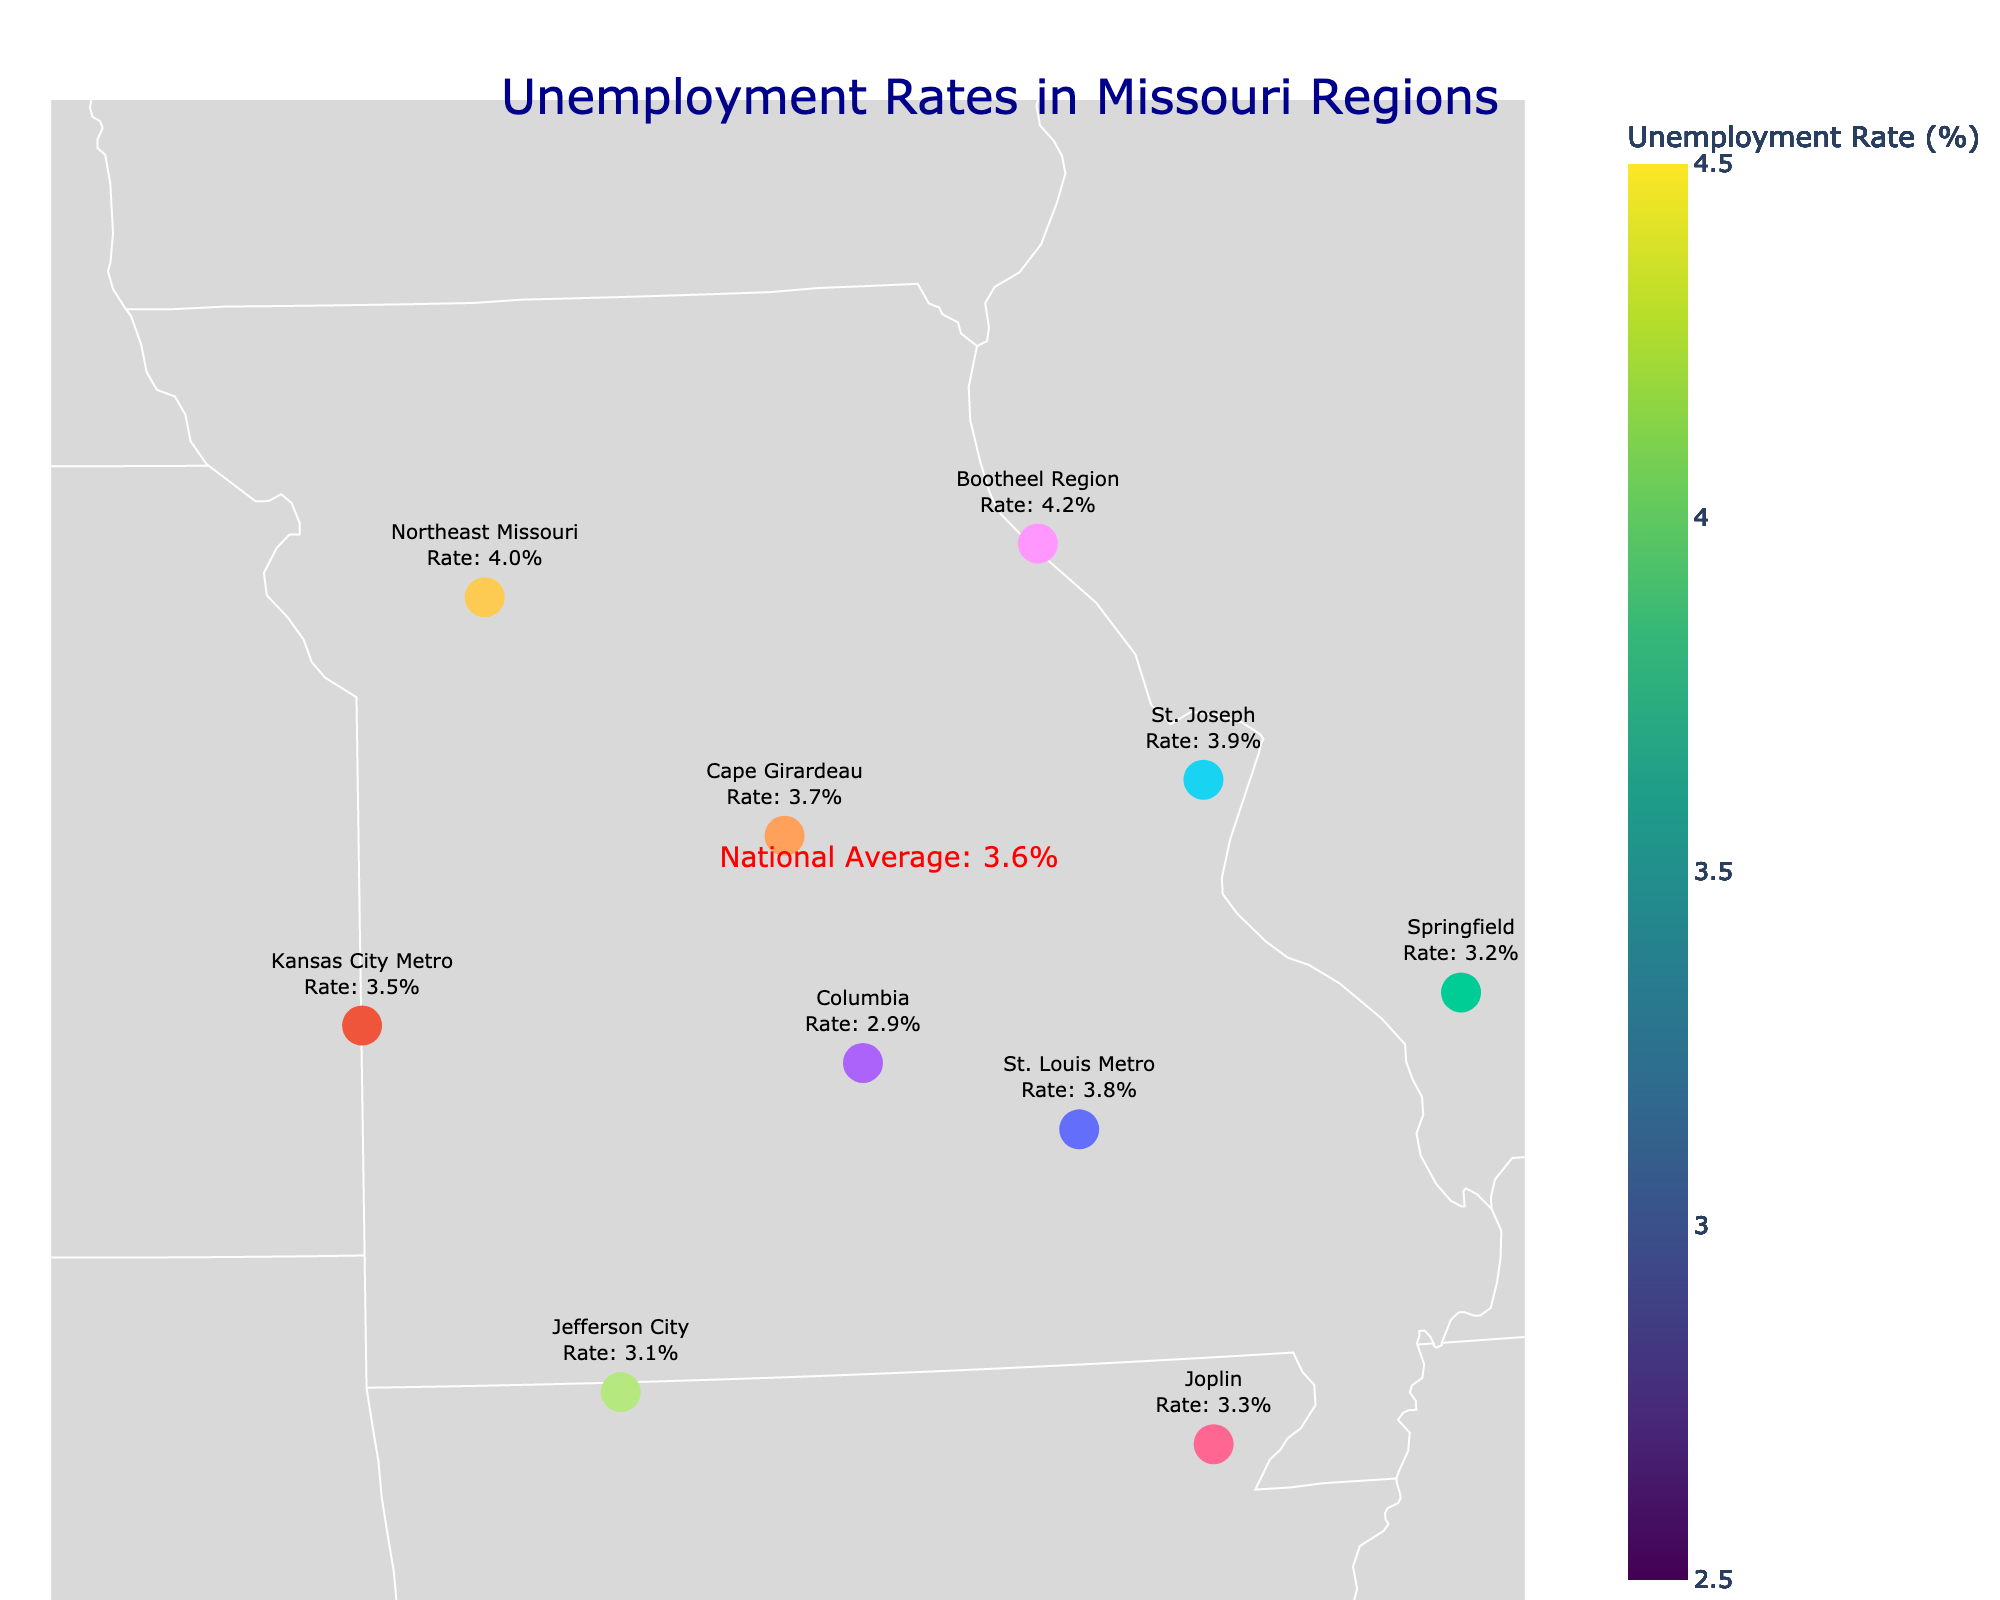What is the unemployment rate in the Bootheel Region? The Bootheel Region's unemployment rate is shown on the figure in the text next to the marker representing the region.
Answer: 4.2% Which region has the highest unemployment rate? By comparing the unemployment rates noted next to each region's marker, the Bootheel Region has the highest rate.
Answer: Bootheel Region How does the unemployment rate in St. Louis Metro compare to the national average? The figure shows that St. Louis Metro has an unemployment rate of 3.8%, compared to the national average of 3.6%.
Answer: Higher What is the difference in unemployment rate between Columbia and St. Joseph? Columbia's rate is 2.9%, and St. Joseph's rate is 3.9%. The difference is calculated as 3.9% - 2.9%.
Answer: 1.0% How many regions have unemployment rates above the national average? By counting the regions with rates higher than 3.6%, we see that St. Louis Metro, Cape Girardeau, St. Joseph, Bootheel Region, and Northeast Missouri are above the national average.
Answer: 5 Which region's unemployment rate is closest to the national average? By comparing the rates to 3.6%, Cape Girardeau’s rate of 3.7% is the closest to the national average.
Answer: Cape Girardeau Is Springfield’s unemployment rate above or below the national average? The figure shows Springfield’s rate at 3.2%, which is less than the national average of 3.6%.
Answer: Below What region has the lowest unemployment rate? The figure indicates that Columbia has the lowest unemployment rate at 2.9%.
Answer: Columbia Compare the unemployment rates of Kansas City Metro and Joplin. Which has a lower rate? Kansas City Metro's rate is 3.5%, while Joplin’s rate is 3.3%. Joplin has a lower rate.
Answer: Joplin Calculate the average unemployment rate for all listed Missouri regions. Summing all the regional rates (3.8 + 3.5 + 3.2 + 2.9 + 3.7 + 3.9 + 3.3 + 3.1 + 4.2 + 4.0) and dividing by the number of regions (10) results in the average. (3.8 + 3.5 + 3.2 + 2.9 + 3.7 + 3.9 + 3.3 + 3.1 + 4.2 + 4.0) / 10 = 3.56%
Answer: 3.56% 